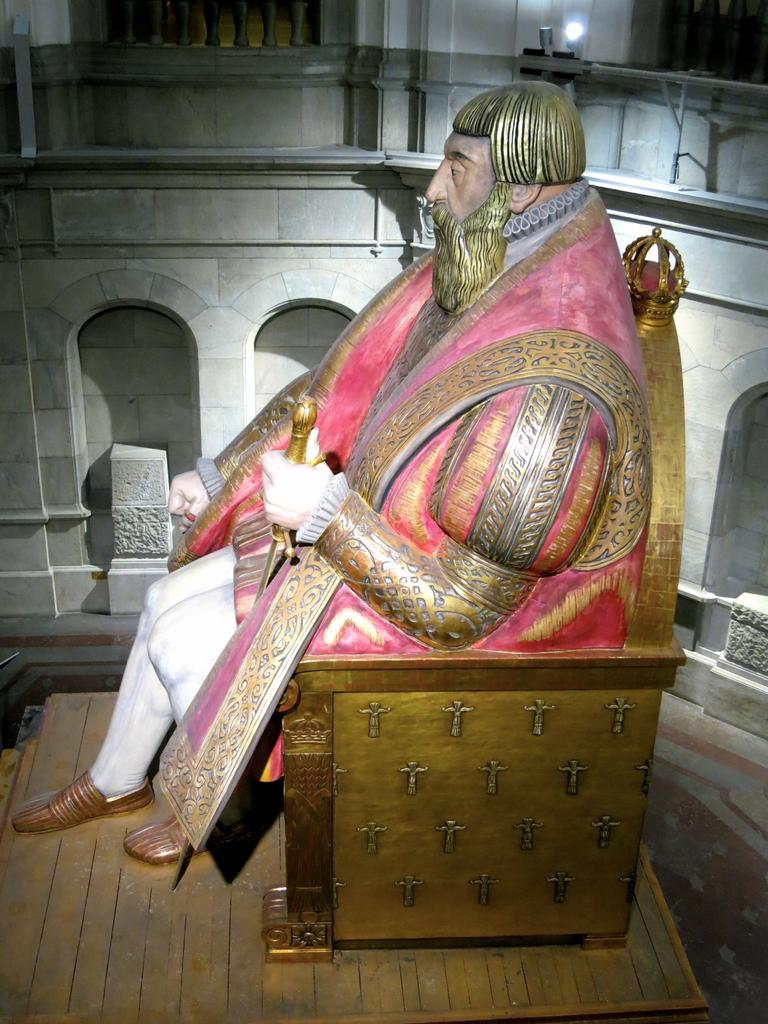What is the main subject of the image? There is a statue in the image. How is the statue positioned in the image? The statue is on a platform. What can be seen in the background of the image? There is a wall, a light, and rods in the background of the image. What type of queen is sitting on the throne in the image? There is no throne or queen present in the image; it features a statue on a platform. What type of camp can be seen in the background of the image? There is no camp visible in the image; it features a wall, a light, and rods in the background. 